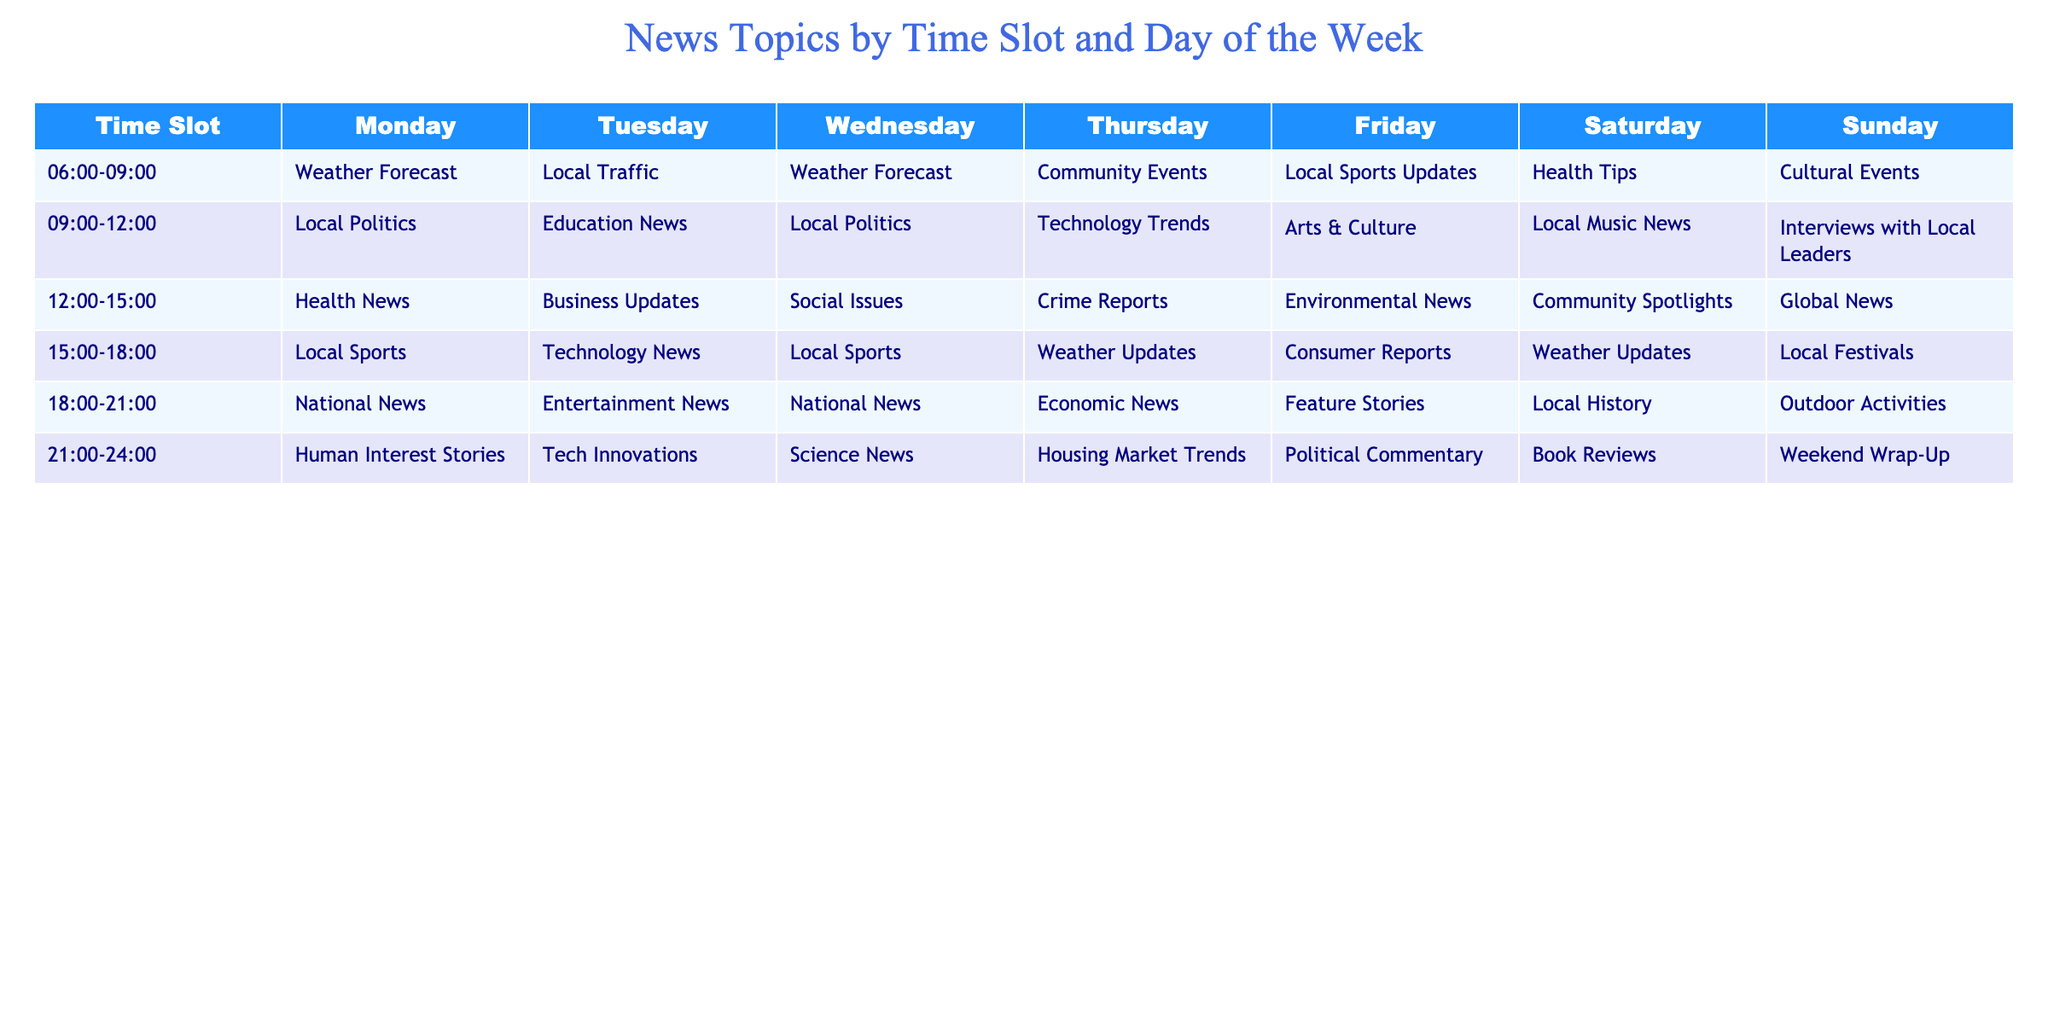What news topic is discussed on Tuesday from 15:00 to 18:00? The table shows that on Tuesday during the time slot of 15:00 to 18:00, the news topic discussed is Technology News.
Answer: Technology News Which day has the most diverse range of topics during the 09:00 to 12:00 time slot? By looking at the topics listed for each day during the 09:00 to 12:00 time slot, we see Local Politics, Education News, Technology Trends, Arts & Culture, and Local Music News. Since no topic repeats, each day has different discussions. Thus, all days here feature the same diversity, but Friday also covers unique themes.
Answer: All days have equal diversity Is there a news topic that appears in both Monday and Wednesday at 06:00 to 09:00? Checking the table for Monday and Wednesday during the 06:00 to 09:00 time slot shows "Weather Forecast" discussed on both days.
Answer: Yes What is the average number of unique topics covered on Sunday across all time slots? The Sunday topics listed are Cultural Events, Interviews with Local Leaders, Global News, Local Festivals, Outdoor Activities, and Weekend Wrap-Up - totaling six unique topics. Since there are six time slots, the average number of unique topics on Sunday is 6/6, which simplifies to 1. Therefore, there are six different topics.
Answer: 6 How many time slots on Thursday include news about Community Events or Local Sports? On Thursday, during the 06:00-09:00 and 15:00-18:00 time slots, Community Events and Local Sports are discussed, which means there are two time slots that include either of them.
Answer: 2 